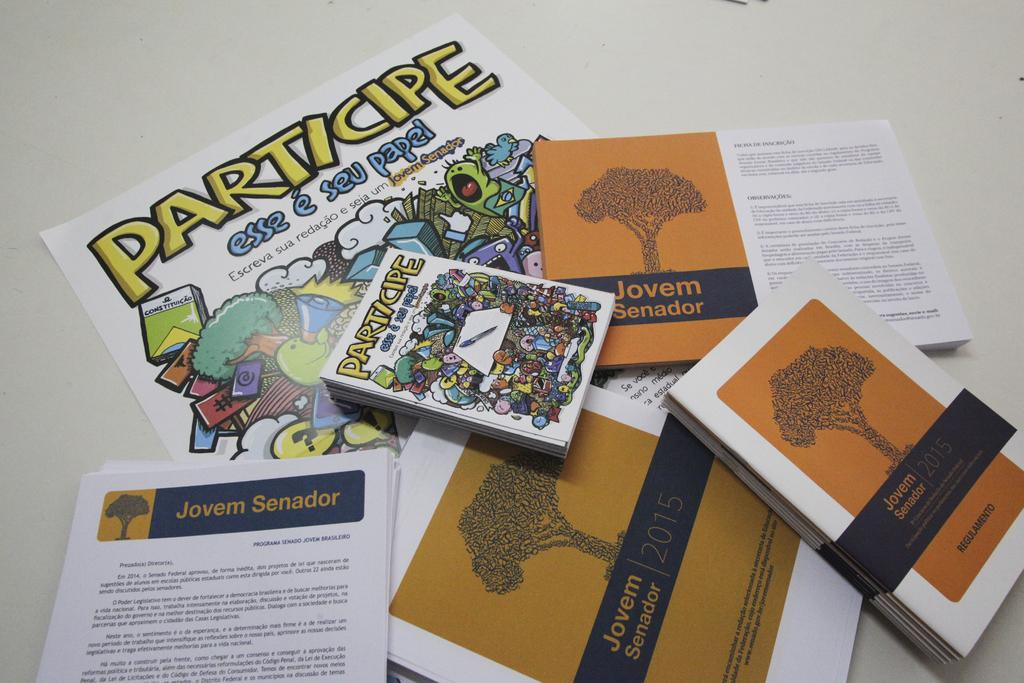<image>
Summarize the visual content of the image. A poster with the word Participe at the top of it. 